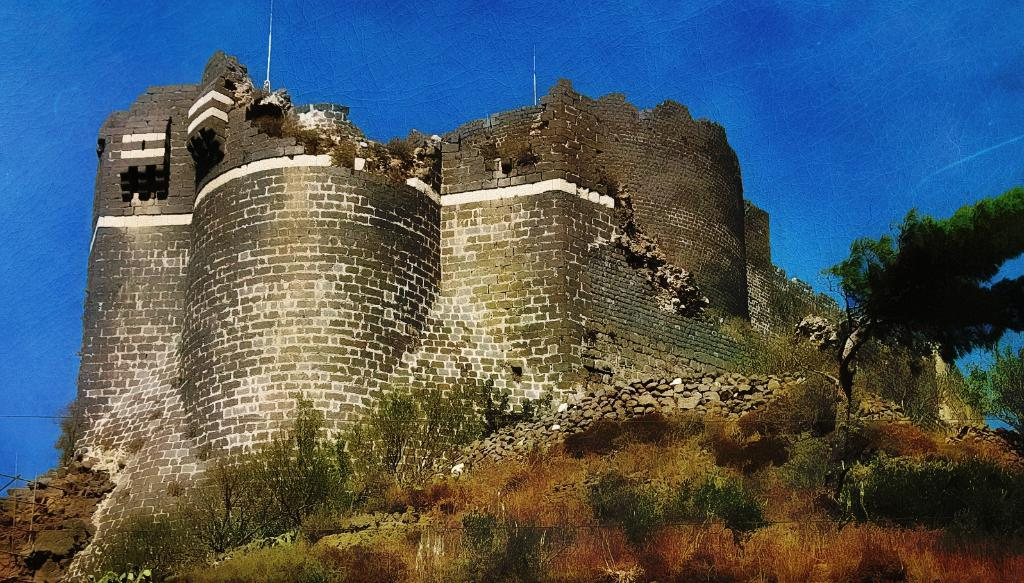What is the main structure in the image? There is a monument in the image. What type of natural elements can be seen in the image? There are plants and trees in the image. What type of terrain is visible in the image? There are stones on the land in the image. What is visible in the background of the image? The sky is visible in the background of the image. What color is the scarf that the monument is wearing in the image? There is no scarf present in the image, as monuments do not wear clothing. 